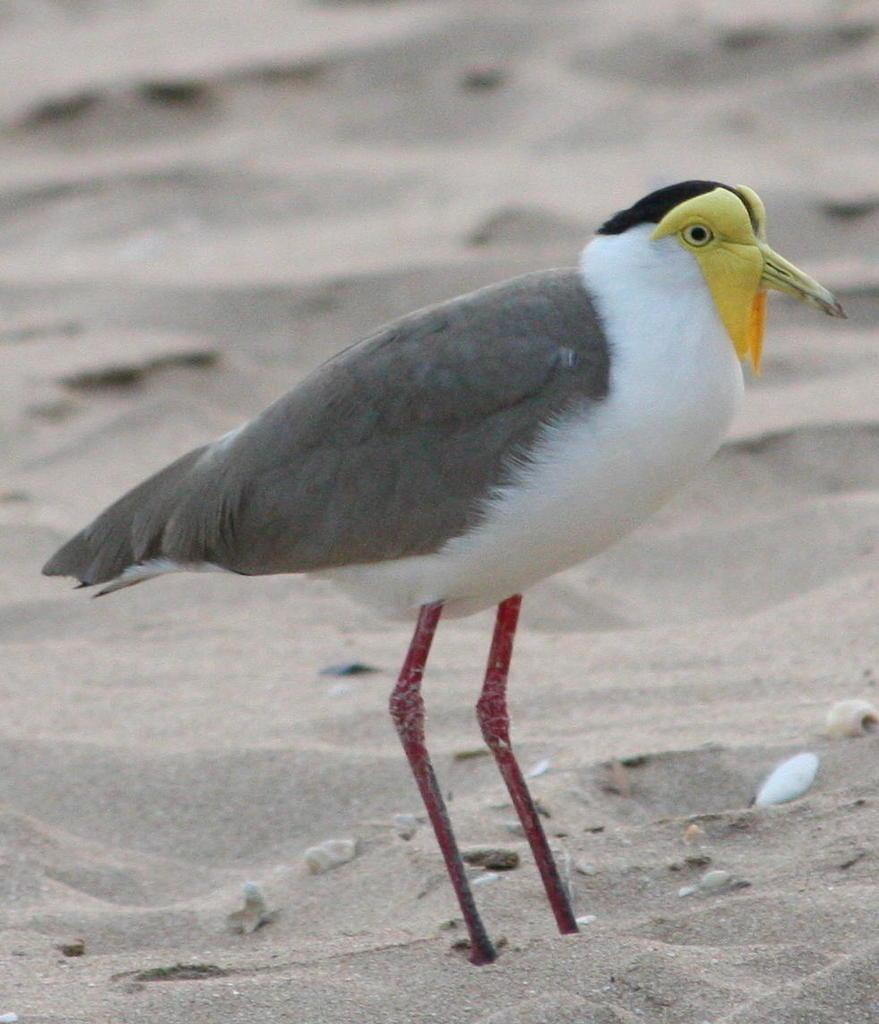What type of animal is present in the image? There is a bird in the image. What is the bird standing on? The bird is standing on the sand. What type of harmony is the bird experiencing in the image? The image does not provide information about the bird's emotional state or any sense of harmony. 